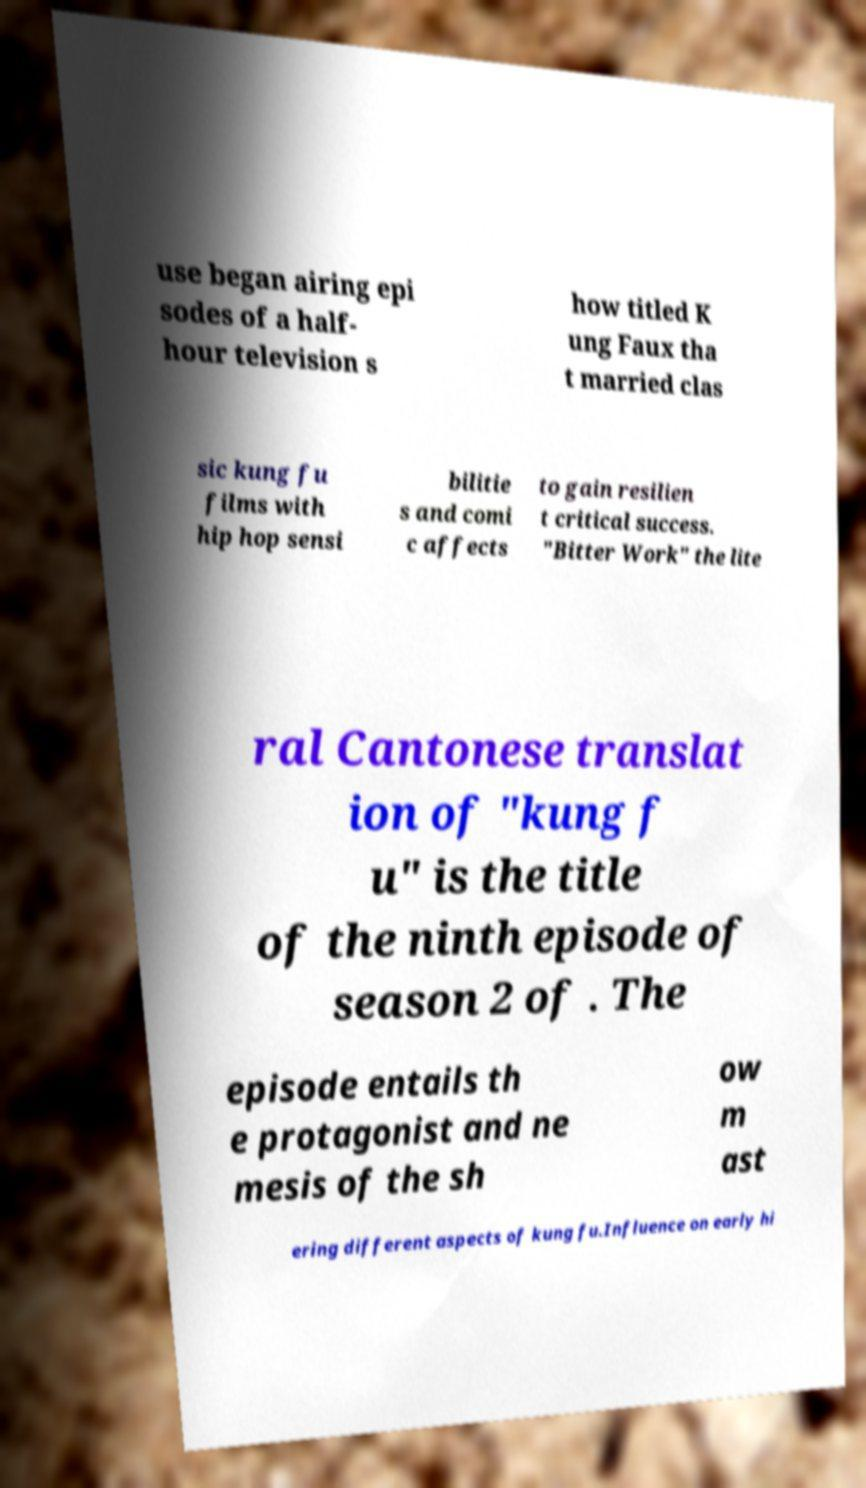Please read and relay the text visible in this image. What does it say? use began airing epi sodes of a half- hour television s how titled K ung Faux tha t married clas sic kung fu films with hip hop sensi bilitie s and comi c affects to gain resilien t critical success. "Bitter Work" the lite ral Cantonese translat ion of "kung f u" is the title of the ninth episode of season 2 of . The episode entails th e protagonist and ne mesis of the sh ow m ast ering different aspects of kung fu.Influence on early hi 